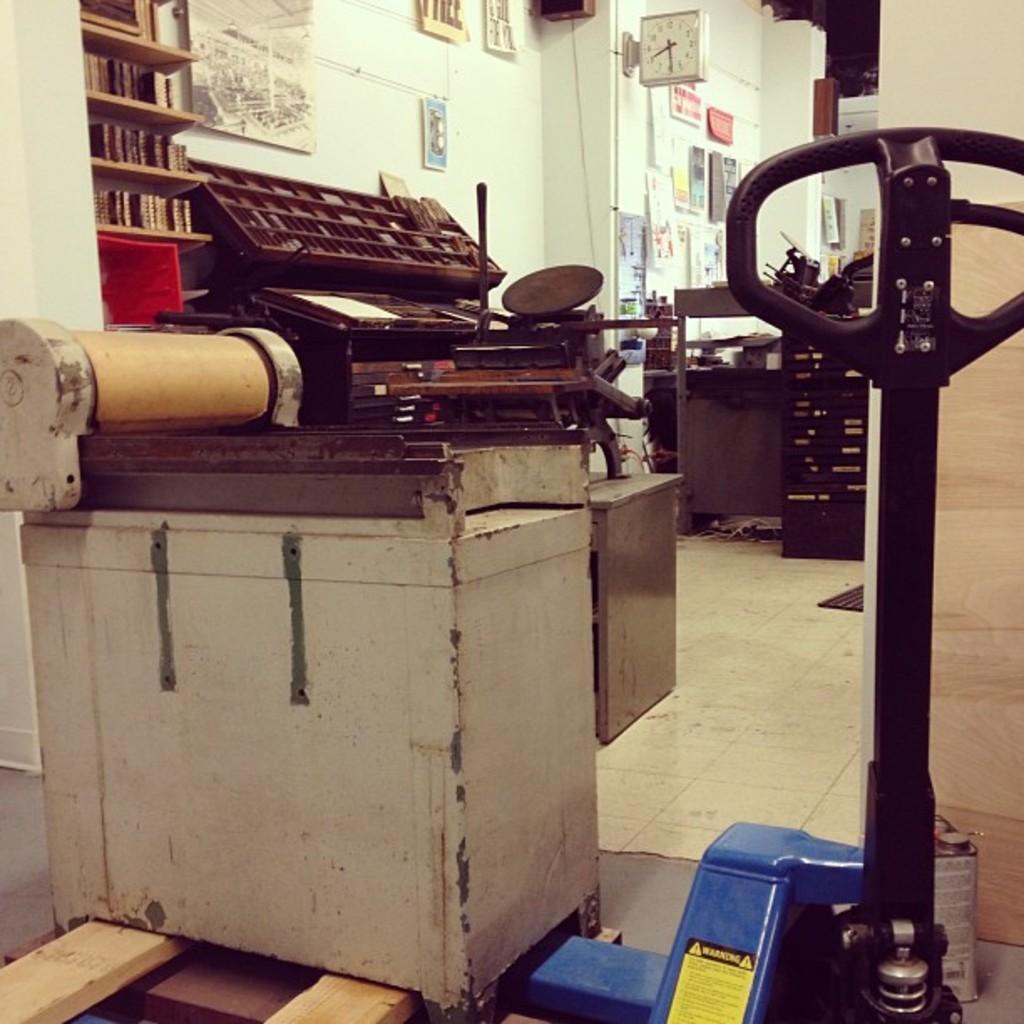Please provide a concise description of this image. In this image I can see few machines, few books in the racks. In the background I can see the clock and few papers attached to the wall and the wall is in white color. 